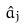<formula> <loc_0><loc_0><loc_500><loc_500>\hat { a } _ { j }</formula> 